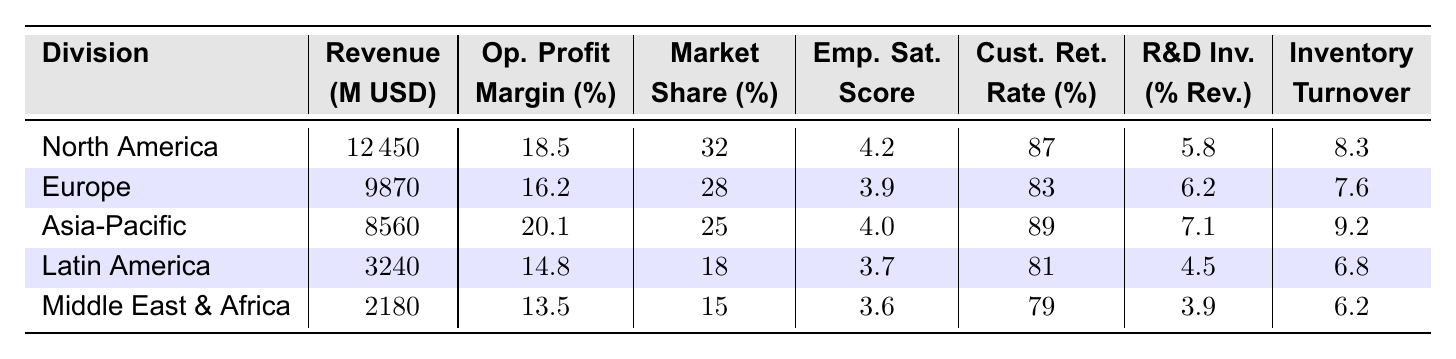What is the revenue of the North America division? The table shows that the revenue for the North America division is listed as 12450 million USD.
Answer: 12450 million USD Which division has the highest operating profit margin? By reviewing the operating profit margin percentages, North America has the highest margin at 18.5%.
Answer: North America Is the customer retention rate for the Asia-Pacific division higher than that of Europe? The customer retention rate for Asia-Pacific is 89%, while for Europe, it is 83%, so Asia-Pacific's rate is higher.
Answer: Yes What is the average employee satisfaction score across all divisions? To find the average, sum all scores (4.2 + 3.9 + 4.0 + 3.7 + 3.6 = 19.4) and divide by the number of divisions (5). The average is 19.4 / 5 = 3.88.
Answer: 3.88 Which division has the lowest revenue and what is it? The table indicates that the Middle East & Africa division has the lowest revenue at 2180 million USD.
Answer: 2180 million USD Is the R&D investment percentage for the Latin America division greater than the Middle East & Africa division? Latin America has an R&D investment of 4.5%, while Middle East & Africa has 3.9%, which means Latin America has a greater percentage.
Answer: Yes What is the difference in operating profit margin between North America and Europe? The operating profit margin for North America is 18.5% and for Europe it is 16.2%. The difference is 18.5 - 16.2 = 2.3%.
Answer: 2.3% Which division has the highest inventory turnover ratio? Looking at the inventory turnover ratios, Asia-Pacific has the highest ratio at 9.2.
Answer: Asia-Pacific What is the total revenue for all divisions combined? Summing the revenues from all divisions (12450 + 9870 + 8560 + 3240 + 2180 = 35980 million USD) gives the total revenue of 35980 million USD.
Answer: 35980 million USD Does the Europe division have a market share greater than 30%? The market share for Europe is 28%, which is less than 30%.
Answer: No What division had an employee satisfaction score of at least 4.0 and what was the score? North America (4.2) and Asia-Pacific (4.0) both had satisfaction scores of at least 4.0.
Answer: North America (4.2) and Asia-Pacific (4.0) 